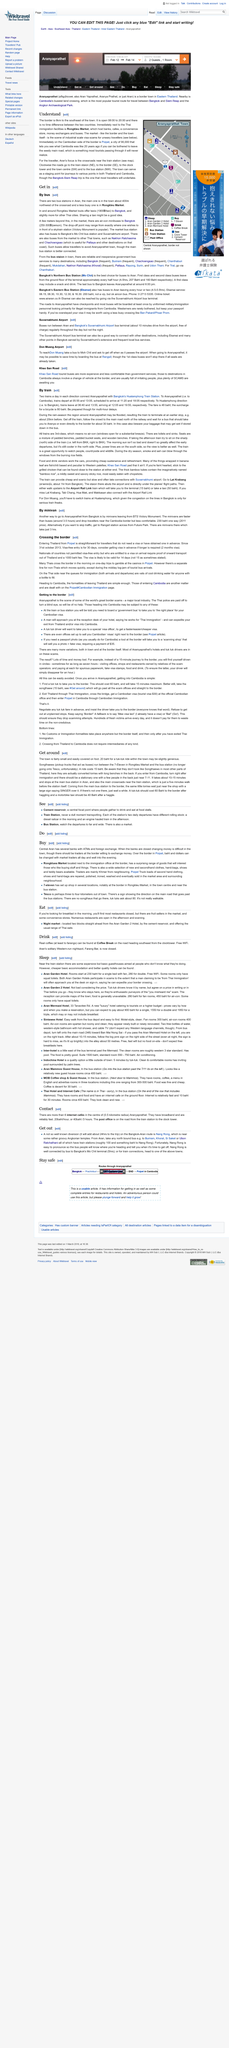List a handful of essential elements in this visual. Sharing a taxi is a good idea as it may be beneficial. You can reach Aran by bus by utilizing two bus stations. The cost of a ride in a Songthaew is 15 baht, as stated. The town of Aran is small, not large. The cost of a tuk-tuk ride to the border should be around 60 Baht, after negotiating the price with the driver. 